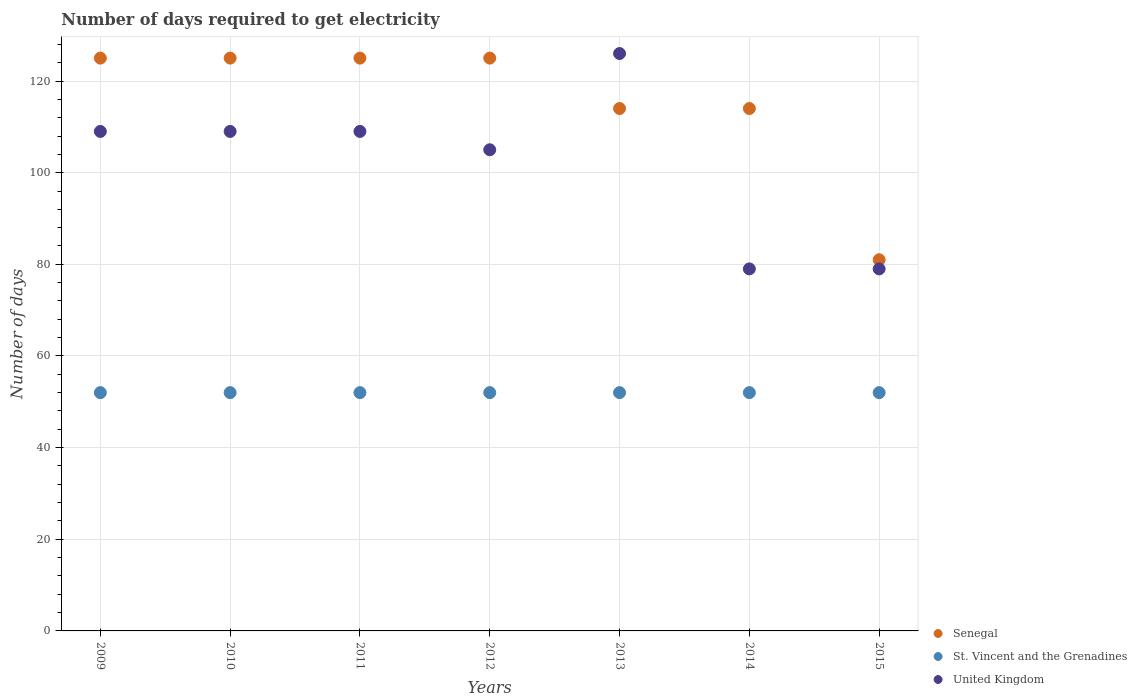What is the number of days required to get electricity in in Senegal in 2015?
Ensure brevity in your answer.  81. Across all years, what is the maximum number of days required to get electricity in in Senegal?
Provide a succinct answer. 125. Across all years, what is the minimum number of days required to get electricity in in United Kingdom?
Your answer should be very brief. 79. In which year was the number of days required to get electricity in in St. Vincent and the Grenadines minimum?
Make the answer very short. 2009. What is the total number of days required to get electricity in in United Kingdom in the graph?
Your response must be concise. 716. What is the difference between the number of days required to get electricity in in United Kingdom in 2012 and that in 2013?
Make the answer very short. -21. What is the difference between the number of days required to get electricity in in Senegal in 2014 and the number of days required to get electricity in in St. Vincent and the Grenadines in 2012?
Offer a terse response. 62. What is the average number of days required to get electricity in in United Kingdom per year?
Your answer should be very brief. 102.29. In the year 2014, what is the difference between the number of days required to get electricity in in United Kingdom and number of days required to get electricity in in St. Vincent and the Grenadines?
Your answer should be very brief. 27. In how many years, is the number of days required to get electricity in in United Kingdom greater than 104 days?
Your response must be concise. 5. What is the ratio of the number of days required to get electricity in in United Kingdom in 2012 to that in 2013?
Provide a short and direct response. 0.83. Is the difference between the number of days required to get electricity in in United Kingdom in 2012 and 2015 greater than the difference between the number of days required to get electricity in in St. Vincent and the Grenadines in 2012 and 2015?
Your answer should be very brief. Yes. What is the difference between the highest and the second highest number of days required to get electricity in in Senegal?
Make the answer very short. 0. What is the difference between the highest and the lowest number of days required to get electricity in in St. Vincent and the Grenadines?
Ensure brevity in your answer.  0. Does the number of days required to get electricity in in United Kingdom monotonically increase over the years?
Provide a succinct answer. No. Is the number of days required to get electricity in in United Kingdom strictly greater than the number of days required to get electricity in in Senegal over the years?
Provide a short and direct response. No. Is the number of days required to get electricity in in St. Vincent and the Grenadines strictly less than the number of days required to get electricity in in Senegal over the years?
Offer a terse response. Yes. Does the graph contain grids?
Keep it short and to the point. Yes. What is the title of the graph?
Offer a very short reply. Number of days required to get electricity. Does "Andorra" appear as one of the legend labels in the graph?
Offer a very short reply. No. What is the label or title of the Y-axis?
Ensure brevity in your answer.  Number of days. What is the Number of days of Senegal in 2009?
Keep it short and to the point. 125. What is the Number of days in United Kingdom in 2009?
Your answer should be compact. 109. What is the Number of days in Senegal in 2010?
Provide a succinct answer. 125. What is the Number of days of United Kingdom in 2010?
Offer a terse response. 109. What is the Number of days in Senegal in 2011?
Your response must be concise. 125. What is the Number of days in St. Vincent and the Grenadines in 2011?
Offer a terse response. 52. What is the Number of days of United Kingdom in 2011?
Your answer should be compact. 109. What is the Number of days of Senegal in 2012?
Give a very brief answer. 125. What is the Number of days in United Kingdom in 2012?
Ensure brevity in your answer.  105. What is the Number of days of Senegal in 2013?
Your answer should be compact. 114. What is the Number of days of St. Vincent and the Grenadines in 2013?
Keep it short and to the point. 52. What is the Number of days in United Kingdom in 2013?
Your answer should be very brief. 126. What is the Number of days in Senegal in 2014?
Ensure brevity in your answer.  114. What is the Number of days of St. Vincent and the Grenadines in 2014?
Make the answer very short. 52. What is the Number of days of United Kingdom in 2014?
Give a very brief answer. 79. What is the Number of days in St. Vincent and the Grenadines in 2015?
Your answer should be very brief. 52. What is the Number of days in United Kingdom in 2015?
Your answer should be compact. 79. Across all years, what is the maximum Number of days in Senegal?
Provide a succinct answer. 125. Across all years, what is the maximum Number of days in St. Vincent and the Grenadines?
Your answer should be very brief. 52. Across all years, what is the maximum Number of days of United Kingdom?
Make the answer very short. 126. Across all years, what is the minimum Number of days in Senegal?
Offer a very short reply. 81. Across all years, what is the minimum Number of days in St. Vincent and the Grenadines?
Offer a terse response. 52. Across all years, what is the minimum Number of days of United Kingdom?
Your response must be concise. 79. What is the total Number of days in Senegal in the graph?
Keep it short and to the point. 809. What is the total Number of days of St. Vincent and the Grenadines in the graph?
Ensure brevity in your answer.  364. What is the total Number of days of United Kingdom in the graph?
Offer a terse response. 716. What is the difference between the Number of days in Senegal in 2009 and that in 2010?
Ensure brevity in your answer.  0. What is the difference between the Number of days in United Kingdom in 2009 and that in 2010?
Provide a succinct answer. 0. What is the difference between the Number of days of Senegal in 2009 and that in 2011?
Offer a very short reply. 0. What is the difference between the Number of days in St. Vincent and the Grenadines in 2009 and that in 2011?
Your response must be concise. 0. What is the difference between the Number of days of Senegal in 2009 and that in 2012?
Ensure brevity in your answer.  0. What is the difference between the Number of days in St. Vincent and the Grenadines in 2009 and that in 2013?
Keep it short and to the point. 0. What is the difference between the Number of days of Senegal in 2009 and that in 2014?
Give a very brief answer. 11. What is the difference between the Number of days in St. Vincent and the Grenadines in 2009 and that in 2014?
Keep it short and to the point. 0. What is the difference between the Number of days in Senegal in 2009 and that in 2015?
Make the answer very short. 44. What is the difference between the Number of days of United Kingdom in 2010 and that in 2011?
Make the answer very short. 0. What is the difference between the Number of days in St. Vincent and the Grenadines in 2010 and that in 2012?
Keep it short and to the point. 0. What is the difference between the Number of days of St. Vincent and the Grenadines in 2010 and that in 2013?
Provide a succinct answer. 0. What is the difference between the Number of days in United Kingdom in 2010 and that in 2013?
Ensure brevity in your answer.  -17. What is the difference between the Number of days of Senegal in 2010 and that in 2014?
Your answer should be compact. 11. What is the difference between the Number of days of St. Vincent and the Grenadines in 2011 and that in 2012?
Provide a succinct answer. 0. What is the difference between the Number of days of United Kingdom in 2011 and that in 2012?
Offer a terse response. 4. What is the difference between the Number of days of St. Vincent and the Grenadines in 2011 and that in 2013?
Your answer should be very brief. 0. What is the difference between the Number of days of Senegal in 2011 and that in 2014?
Provide a short and direct response. 11. What is the difference between the Number of days in Senegal in 2011 and that in 2015?
Keep it short and to the point. 44. What is the difference between the Number of days in United Kingdom in 2012 and that in 2013?
Provide a short and direct response. -21. What is the difference between the Number of days in United Kingdom in 2012 and that in 2014?
Provide a short and direct response. 26. What is the difference between the Number of days in United Kingdom in 2012 and that in 2015?
Your answer should be very brief. 26. What is the difference between the Number of days in Senegal in 2013 and that in 2014?
Keep it short and to the point. 0. What is the difference between the Number of days of St. Vincent and the Grenadines in 2013 and that in 2014?
Provide a short and direct response. 0. What is the difference between the Number of days of Senegal in 2013 and that in 2015?
Provide a short and direct response. 33. What is the difference between the Number of days in St. Vincent and the Grenadines in 2013 and that in 2015?
Ensure brevity in your answer.  0. What is the difference between the Number of days of United Kingdom in 2014 and that in 2015?
Give a very brief answer. 0. What is the difference between the Number of days of Senegal in 2009 and the Number of days of St. Vincent and the Grenadines in 2010?
Offer a very short reply. 73. What is the difference between the Number of days in Senegal in 2009 and the Number of days in United Kingdom in 2010?
Your response must be concise. 16. What is the difference between the Number of days of St. Vincent and the Grenadines in 2009 and the Number of days of United Kingdom in 2010?
Make the answer very short. -57. What is the difference between the Number of days of St. Vincent and the Grenadines in 2009 and the Number of days of United Kingdom in 2011?
Your answer should be very brief. -57. What is the difference between the Number of days in St. Vincent and the Grenadines in 2009 and the Number of days in United Kingdom in 2012?
Your answer should be compact. -53. What is the difference between the Number of days of St. Vincent and the Grenadines in 2009 and the Number of days of United Kingdom in 2013?
Keep it short and to the point. -74. What is the difference between the Number of days in Senegal in 2009 and the Number of days in St. Vincent and the Grenadines in 2015?
Ensure brevity in your answer.  73. What is the difference between the Number of days in Senegal in 2009 and the Number of days in United Kingdom in 2015?
Offer a very short reply. 46. What is the difference between the Number of days in St. Vincent and the Grenadines in 2009 and the Number of days in United Kingdom in 2015?
Make the answer very short. -27. What is the difference between the Number of days of St. Vincent and the Grenadines in 2010 and the Number of days of United Kingdom in 2011?
Offer a very short reply. -57. What is the difference between the Number of days of St. Vincent and the Grenadines in 2010 and the Number of days of United Kingdom in 2012?
Provide a short and direct response. -53. What is the difference between the Number of days of St. Vincent and the Grenadines in 2010 and the Number of days of United Kingdom in 2013?
Your response must be concise. -74. What is the difference between the Number of days in St. Vincent and the Grenadines in 2010 and the Number of days in United Kingdom in 2014?
Provide a short and direct response. -27. What is the difference between the Number of days in Senegal in 2010 and the Number of days in St. Vincent and the Grenadines in 2015?
Keep it short and to the point. 73. What is the difference between the Number of days in Senegal in 2010 and the Number of days in United Kingdom in 2015?
Provide a succinct answer. 46. What is the difference between the Number of days in Senegal in 2011 and the Number of days in United Kingdom in 2012?
Ensure brevity in your answer.  20. What is the difference between the Number of days in St. Vincent and the Grenadines in 2011 and the Number of days in United Kingdom in 2012?
Your answer should be compact. -53. What is the difference between the Number of days of St. Vincent and the Grenadines in 2011 and the Number of days of United Kingdom in 2013?
Your answer should be very brief. -74. What is the difference between the Number of days in St. Vincent and the Grenadines in 2011 and the Number of days in United Kingdom in 2014?
Your response must be concise. -27. What is the difference between the Number of days in Senegal in 2011 and the Number of days in St. Vincent and the Grenadines in 2015?
Your answer should be compact. 73. What is the difference between the Number of days in St. Vincent and the Grenadines in 2011 and the Number of days in United Kingdom in 2015?
Keep it short and to the point. -27. What is the difference between the Number of days of Senegal in 2012 and the Number of days of St. Vincent and the Grenadines in 2013?
Ensure brevity in your answer.  73. What is the difference between the Number of days of Senegal in 2012 and the Number of days of United Kingdom in 2013?
Offer a terse response. -1. What is the difference between the Number of days of St. Vincent and the Grenadines in 2012 and the Number of days of United Kingdom in 2013?
Offer a terse response. -74. What is the difference between the Number of days in Senegal in 2012 and the Number of days in United Kingdom in 2014?
Provide a short and direct response. 46. What is the difference between the Number of days of St. Vincent and the Grenadines in 2012 and the Number of days of United Kingdom in 2014?
Your response must be concise. -27. What is the difference between the Number of days in Senegal in 2012 and the Number of days in St. Vincent and the Grenadines in 2015?
Your answer should be compact. 73. What is the difference between the Number of days in Senegal in 2012 and the Number of days in United Kingdom in 2015?
Offer a terse response. 46. What is the difference between the Number of days of Senegal in 2013 and the Number of days of St. Vincent and the Grenadines in 2014?
Your answer should be compact. 62. What is the difference between the Number of days in St. Vincent and the Grenadines in 2013 and the Number of days in United Kingdom in 2014?
Keep it short and to the point. -27. What is the difference between the Number of days in Senegal in 2013 and the Number of days in St. Vincent and the Grenadines in 2015?
Your response must be concise. 62. What is the difference between the Number of days of Senegal in 2013 and the Number of days of United Kingdom in 2015?
Your answer should be very brief. 35. What is the difference between the Number of days of St. Vincent and the Grenadines in 2014 and the Number of days of United Kingdom in 2015?
Give a very brief answer. -27. What is the average Number of days of Senegal per year?
Offer a terse response. 115.57. What is the average Number of days of United Kingdom per year?
Provide a succinct answer. 102.29. In the year 2009, what is the difference between the Number of days of Senegal and Number of days of St. Vincent and the Grenadines?
Provide a succinct answer. 73. In the year 2009, what is the difference between the Number of days of St. Vincent and the Grenadines and Number of days of United Kingdom?
Give a very brief answer. -57. In the year 2010, what is the difference between the Number of days in St. Vincent and the Grenadines and Number of days in United Kingdom?
Keep it short and to the point. -57. In the year 2011, what is the difference between the Number of days of Senegal and Number of days of United Kingdom?
Keep it short and to the point. 16. In the year 2011, what is the difference between the Number of days of St. Vincent and the Grenadines and Number of days of United Kingdom?
Make the answer very short. -57. In the year 2012, what is the difference between the Number of days in Senegal and Number of days in United Kingdom?
Offer a terse response. 20. In the year 2012, what is the difference between the Number of days in St. Vincent and the Grenadines and Number of days in United Kingdom?
Ensure brevity in your answer.  -53. In the year 2013, what is the difference between the Number of days in St. Vincent and the Grenadines and Number of days in United Kingdom?
Your answer should be very brief. -74. In the year 2014, what is the difference between the Number of days in Senegal and Number of days in St. Vincent and the Grenadines?
Your answer should be compact. 62. In the year 2014, what is the difference between the Number of days of Senegal and Number of days of United Kingdom?
Provide a short and direct response. 35. What is the ratio of the Number of days of Senegal in 2009 to that in 2011?
Your answer should be very brief. 1. What is the ratio of the Number of days in United Kingdom in 2009 to that in 2012?
Your answer should be compact. 1.04. What is the ratio of the Number of days in Senegal in 2009 to that in 2013?
Keep it short and to the point. 1.1. What is the ratio of the Number of days of United Kingdom in 2009 to that in 2013?
Provide a short and direct response. 0.87. What is the ratio of the Number of days in Senegal in 2009 to that in 2014?
Provide a succinct answer. 1.1. What is the ratio of the Number of days of St. Vincent and the Grenadines in 2009 to that in 2014?
Give a very brief answer. 1. What is the ratio of the Number of days in United Kingdom in 2009 to that in 2014?
Provide a succinct answer. 1.38. What is the ratio of the Number of days in Senegal in 2009 to that in 2015?
Give a very brief answer. 1.54. What is the ratio of the Number of days in St. Vincent and the Grenadines in 2009 to that in 2015?
Keep it short and to the point. 1. What is the ratio of the Number of days of United Kingdom in 2009 to that in 2015?
Ensure brevity in your answer.  1.38. What is the ratio of the Number of days of St. Vincent and the Grenadines in 2010 to that in 2011?
Keep it short and to the point. 1. What is the ratio of the Number of days of United Kingdom in 2010 to that in 2012?
Ensure brevity in your answer.  1.04. What is the ratio of the Number of days of Senegal in 2010 to that in 2013?
Keep it short and to the point. 1.1. What is the ratio of the Number of days in St. Vincent and the Grenadines in 2010 to that in 2013?
Offer a terse response. 1. What is the ratio of the Number of days of United Kingdom in 2010 to that in 2013?
Provide a succinct answer. 0.87. What is the ratio of the Number of days of Senegal in 2010 to that in 2014?
Keep it short and to the point. 1.1. What is the ratio of the Number of days in St. Vincent and the Grenadines in 2010 to that in 2014?
Your answer should be compact. 1. What is the ratio of the Number of days in United Kingdom in 2010 to that in 2014?
Offer a terse response. 1.38. What is the ratio of the Number of days of Senegal in 2010 to that in 2015?
Make the answer very short. 1.54. What is the ratio of the Number of days of United Kingdom in 2010 to that in 2015?
Make the answer very short. 1.38. What is the ratio of the Number of days of Senegal in 2011 to that in 2012?
Provide a succinct answer. 1. What is the ratio of the Number of days in St. Vincent and the Grenadines in 2011 to that in 2012?
Offer a very short reply. 1. What is the ratio of the Number of days in United Kingdom in 2011 to that in 2012?
Your answer should be compact. 1.04. What is the ratio of the Number of days of Senegal in 2011 to that in 2013?
Offer a very short reply. 1.1. What is the ratio of the Number of days in St. Vincent and the Grenadines in 2011 to that in 2013?
Provide a short and direct response. 1. What is the ratio of the Number of days in United Kingdom in 2011 to that in 2013?
Offer a very short reply. 0.87. What is the ratio of the Number of days in Senegal in 2011 to that in 2014?
Your response must be concise. 1.1. What is the ratio of the Number of days in United Kingdom in 2011 to that in 2014?
Provide a short and direct response. 1.38. What is the ratio of the Number of days in Senegal in 2011 to that in 2015?
Offer a very short reply. 1.54. What is the ratio of the Number of days of United Kingdom in 2011 to that in 2015?
Make the answer very short. 1.38. What is the ratio of the Number of days in Senegal in 2012 to that in 2013?
Your answer should be very brief. 1.1. What is the ratio of the Number of days in Senegal in 2012 to that in 2014?
Your answer should be compact. 1.1. What is the ratio of the Number of days of United Kingdom in 2012 to that in 2014?
Offer a very short reply. 1.33. What is the ratio of the Number of days in Senegal in 2012 to that in 2015?
Give a very brief answer. 1.54. What is the ratio of the Number of days of St. Vincent and the Grenadines in 2012 to that in 2015?
Your response must be concise. 1. What is the ratio of the Number of days in United Kingdom in 2012 to that in 2015?
Provide a succinct answer. 1.33. What is the ratio of the Number of days of Senegal in 2013 to that in 2014?
Your answer should be compact. 1. What is the ratio of the Number of days in United Kingdom in 2013 to that in 2014?
Offer a terse response. 1.59. What is the ratio of the Number of days in Senegal in 2013 to that in 2015?
Your answer should be very brief. 1.41. What is the ratio of the Number of days in United Kingdom in 2013 to that in 2015?
Provide a succinct answer. 1.59. What is the ratio of the Number of days in Senegal in 2014 to that in 2015?
Make the answer very short. 1.41. What is the ratio of the Number of days in St. Vincent and the Grenadines in 2014 to that in 2015?
Give a very brief answer. 1. What is the difference between the highest and the second highest Number of days of United Kingdom?
Give a very brief answer. 17. What is the difference between the highest and the lowest Number of days of Senegal?
Offer a very short reply. 44. What is the difference between the highest and the lowest Number of days in St. Vincent and the Grenadines?
Give a very brief answer. 0. 